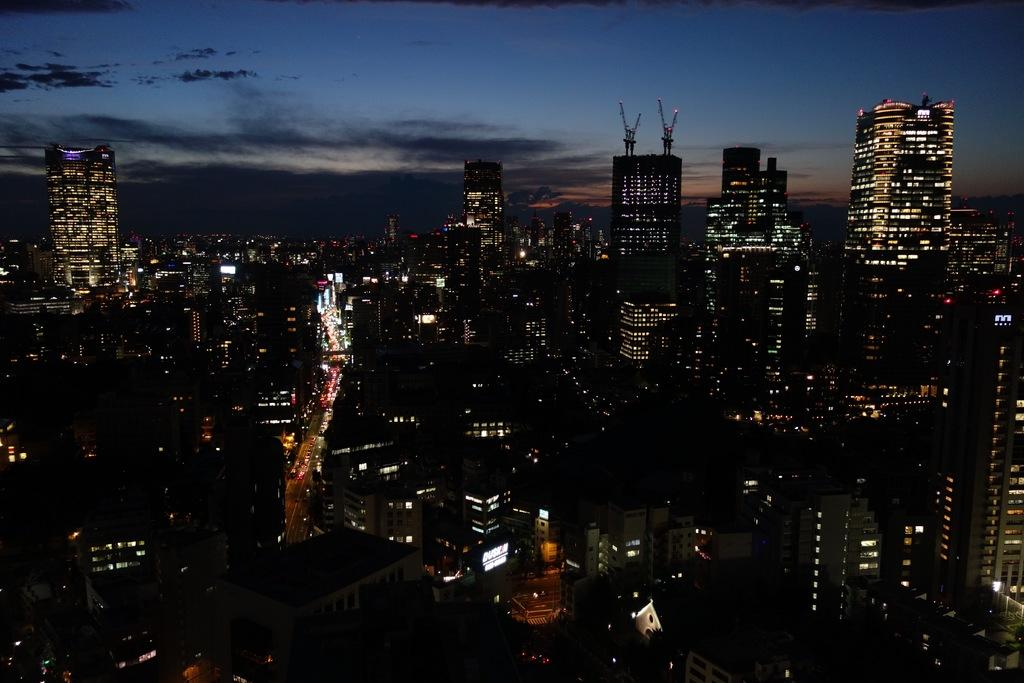What is the lighting condition in the image? The image was clicked in the dark. What can be seen in the image besides the dark lighting? There are many buildings in the image. What feature do the buildings have? The buildings have lights. What is visible at the top of the image? The sky is visible at the top of the image. How far away are the men from the buildings in the image? There are no men present in the image, so it is not possible to determine their distance from the buildings. 